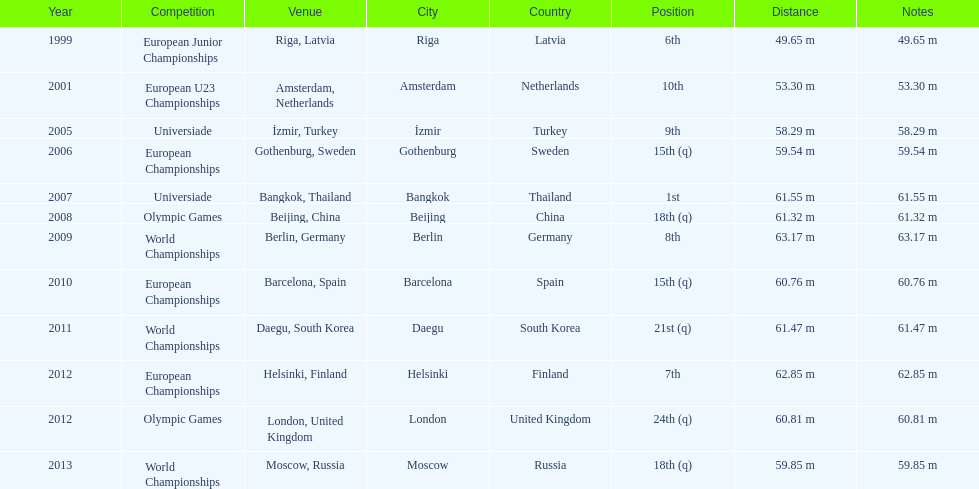What are the total number of times european junior championships is listed as the competition? 1. 